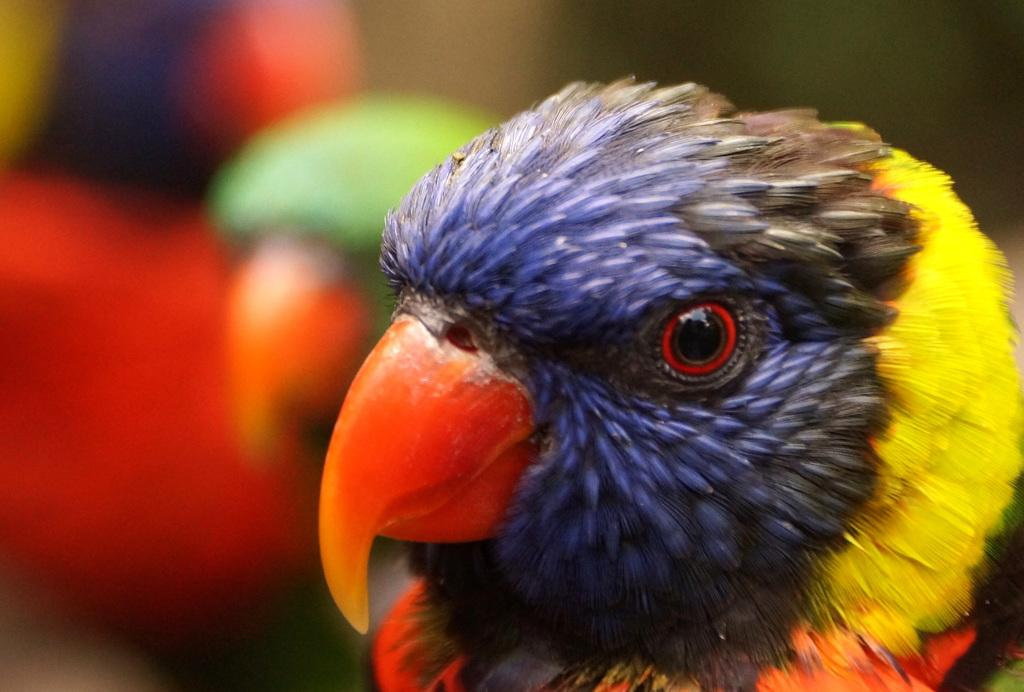What type of animals are present in the image? There are parrots in the image. Can you describe the appearance of the parrots? The provided facts do not include a description of the parrots' appearance. Are the parrots in a specific location or setting in the image? The provided facts do not specify a location or setting for the parrots. What type of wren can be seen in the image? There is no wren present in the image; it features parrots instead. How many times do the parrots fold their wings in the image? The provided facts do not mention the parrots folding their wings, so it is not possible to answer this question. 